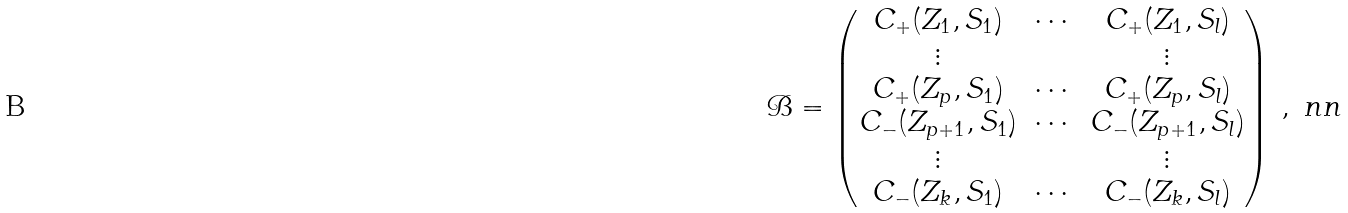<formula> <loc_0><loc_0><loc_500><loc_500>\mathcal { B } = \begin{pmatrix} C _ { + } ( Z _ { 1 } , S _ { 1 } ) & \cdots & C _ { + } ( Z _ { 1 } , S _ { l } ) \\ \vdots & \ & \vdots \\ C _ { + } ( Z _ { p } , S _ { 1 } ) & \cdots & C _ { + } ( Z _ { p } , S _ { l } ) \\ C _ { - } ( Z _ { p + 1 } , S _ { 1 } ) & \cdots & C _ { - } ( Z _ { p + 1 } , S _ { l } ) \\ \vdots & \ & \vdots \\ C _ { - } ( Z _ { k } , S _ { 1 } ) & \cdots & C _ { - } ( Z _ { k } , S _ { l } ) \end{pmatrix} \, , \ n n</formula> 